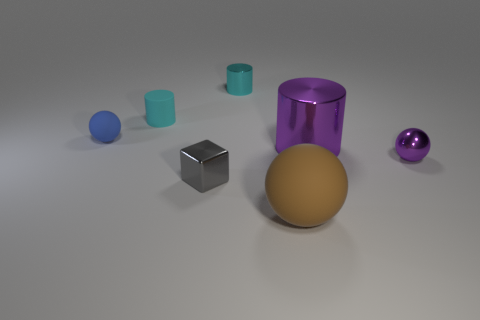Does the large brown rubber object have the same shape as the cyan matte object?
Provide a succinct answer. No. There is a big object that is behind the rubber ball to the right of the small cyan matte object; how many blue things are on the left side of it?
Give a very brief answer. 1. What is the material of the thing that is both in front of the small blue matte object and on the left side of the small cyan shiny object?
Keep it short and to the point. Metal. There is a object that is both behind the small blue matte ball and on the left side of the tiny gray cube; what is its color?
Your answer should be compact. Cyan. Are there any other things that have the same color as the large cylinder?
Make the answer very short. Yes. The object on the left side of the small cyan object in front of the small cylinder on the right side of the tiny cyan matte cylinder is what shape?
Keep it short and to the point. Sphere. The big metallic thing that is the same shape as the small cyan matte thing is what color?
Keep it short and to the point. Purple. There is a rubber sphere that is in front of the object to the right of the large purple cylinder; what color is it?
Your response must be concise. Brown. There is a cyan matte object that is the same shape as the large purple object; what is its size?
Provide a succinct answer. Small. What number of other tiny cubes are made of the same material as the small block?
Ensure brevity in your answer.  0. 